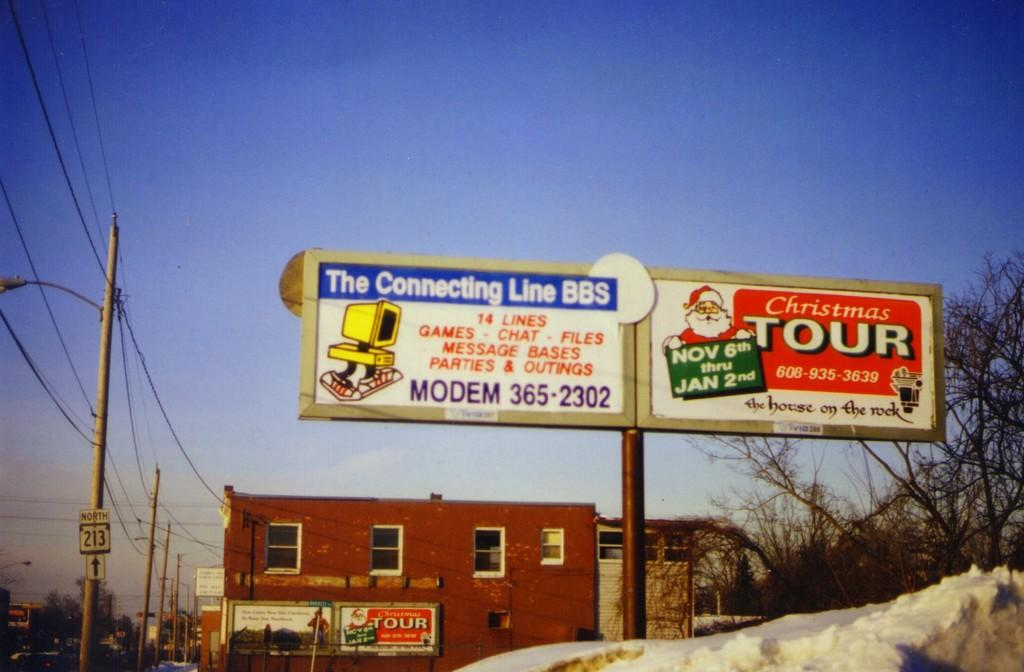<image>
Provide a brief description of the given image. the billboard for christmas tour is open nov8 to jan 2 